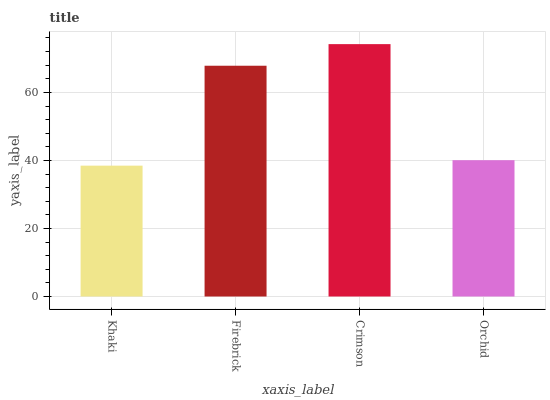Is Khaki the minimum?
Answer yes or no. Yes. Is Crimson the maximum?
Answer yes or no. Yes. Is Firebrick the minimum?
Answer yes or no. No. Is Firebrick the maximum?
Answer yes or no. No. Is Firebrick greater than Khaki?
Answer yes or no. Yes. Is Khaki less than Firebrick?
Answer yes or no. Yes. Is Khaki greater than Firebrick?
Answer yes or no. No. Is Firebrick less than Khaki?
Answer yes or no. No. Is Firebrick the high median?
Answer yes or no. Yes. Is Orchid the low median?
Answer yes or no. Yes. Is Khaki the high median?
Answer yes or no. No. Is Khaki the low median?
Answer yes or no. No. 